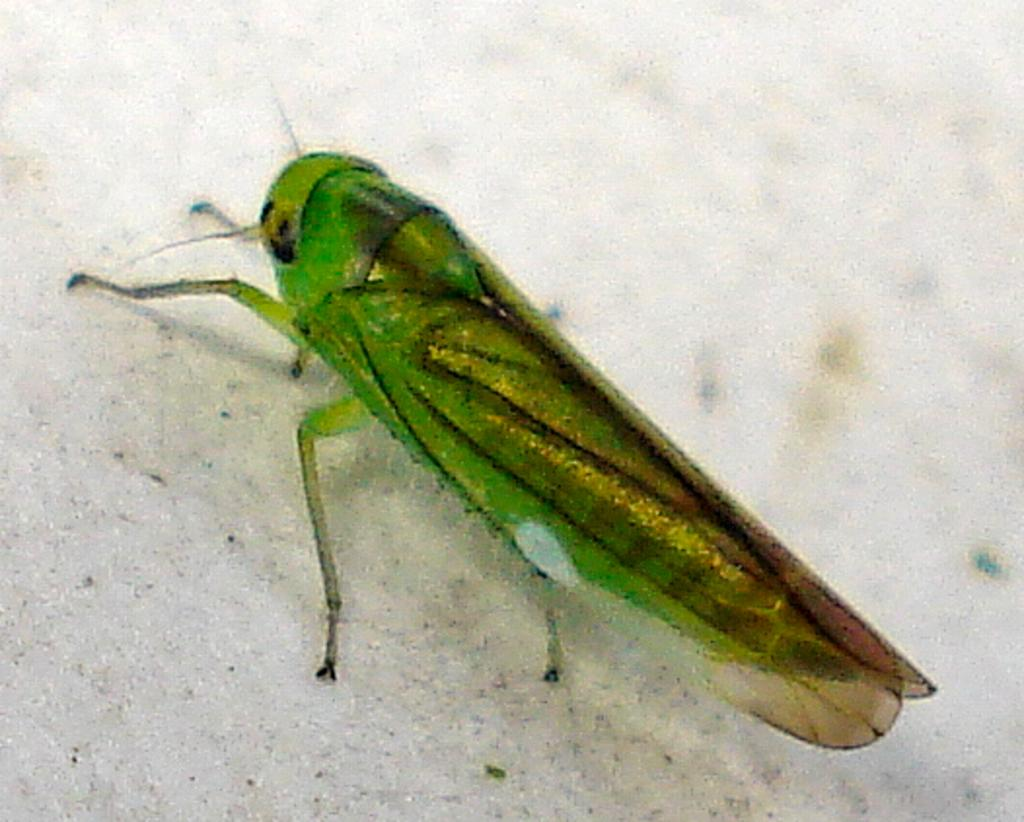What is present on the marble surface in the image? There is an insect on the marble surface in the image. What can be observed about the insect's appearance? The insect has green and brown colors. What type of mint is growing on the insect's body in the image? There is no mint or any plant growing on the insect's body in the image. 